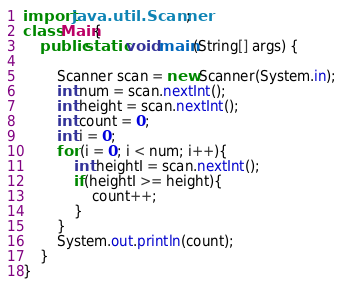<code> <loc_0><loc_0><loc_500><loc_500><_Java_>import java.util.Scanner;
class Main{
    public static void main(String[] args) {
        
        Scanner scan = new Scanner(System.in);
        int num = scan.nextInt();
        int height = scan.nextInt();
        int count = 0;
        int i = 0;
        for (i = 0; i < num; i++){
            int heightI = scan.nextInt();
            if(heightI >= height){
                count++;
            }
        }
        System.out.println(count);
    }
}</code> 